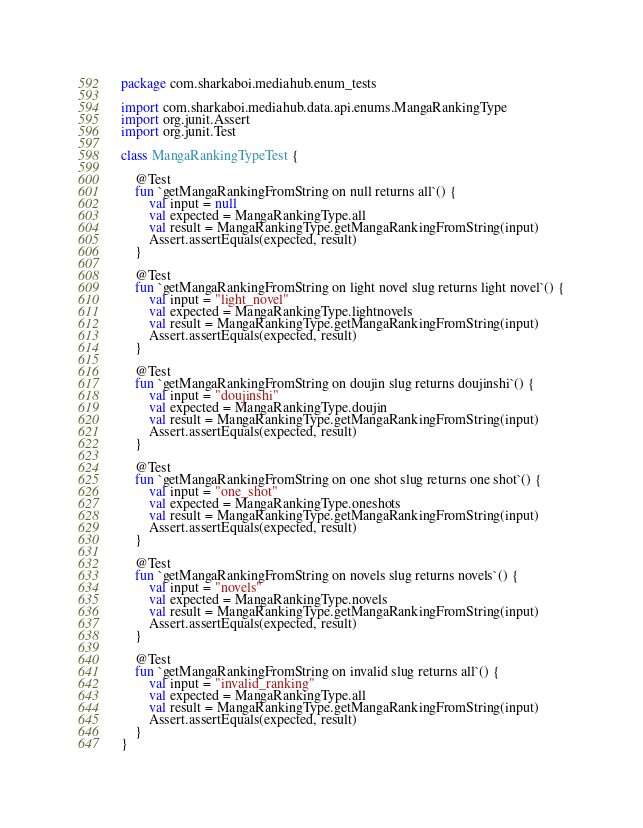<code> <loc_0><loc_0><loc_500><loc_500><_Kotlin_>package com.sharkaboi.mediahub.enum_tests

import com.sharkaboi.mediahub.data.api.enums.MangaRankingType
import org.junit.Assert
import org.junit.Test

class MangaRankingTypeTest {

    @Test
    fun `getMangaRankingFromString on null returns all`() {
        val input = null
        val expected = MangaRankingType.all
        val result = MangaRankingType.getMangaRankingFromString(input)
        Assert.assertEquals(expected, result)
    }

    @Test
    fun `getMangaRankingFromString on light novel slug returns light novel`() {
        val input = "light_novel"
        val expected = MangaRankingType.lightnovels
        val result = MangaRankingType.getMangaRankingFromString(input)
        Assert.assertEquals(expected, result)
    }

    @Test
    fun `getMangaRankingFromString on doujin slug returns doujinshi`() {
        val input = "doujinshi"
        val expected = MangaRankingType.doujin
        val result = MangaRankingType.getMangaRankingFromString(input)
        Assert.assertEquals(expected, result)
    }

    @Test
    fun `getMangaRankingFromString on one shot slug returns one shot`() {
        val input = "one_shot"
        val expected = MangaRankingType.oneshots
        val result = MangaRankingType.getMangaRankingFromString(input)
        Assert.assertEquals(expected, result)
    }

    @Test
    fun `getMangaRankingFromString on novels slug returns novels`() {
        val input = "novels"
        val expected = MangaRankingType.novels
        val result = MangaRankingType.getMangaRankingFromString(input)
        Assert.assertEquals(expected, result)
    }

    @Test
    fun `getMangaRankingFromString on invalid slug returns all`() {
        val input = "invalid_ranking"
        val expected = MangaRankingType.all
        val result = MangaRankingType.getMangaRankingFromString(input)
        Assert.assertEquals(expected, result)
    }
}
</code> 